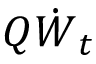Convert formula to latex. <formula><loc_0><loc_0><loc_500><loc_500>Q \dot { W } _ { t }</formula> 